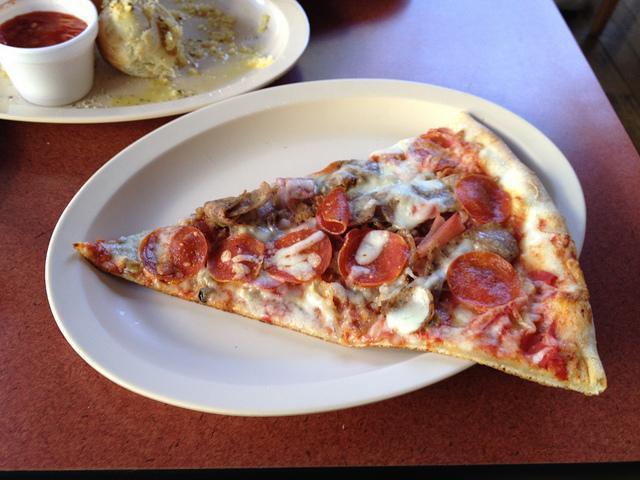Is the caption "The pizza is at the edge of the dining table." a true representation of the image?
Answer yes or no. No. 